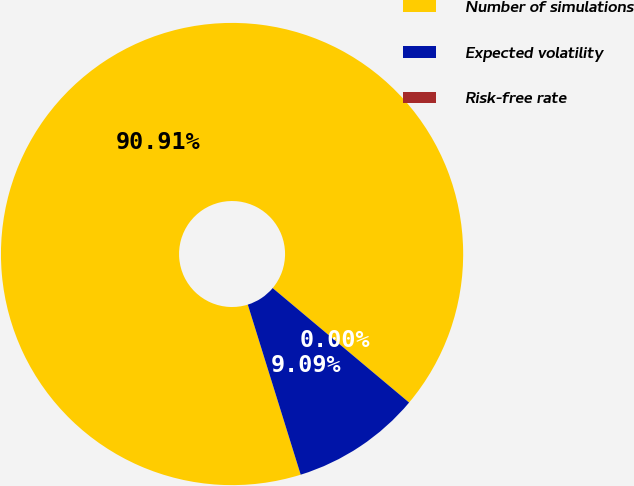Convert chart. <chart><loc_0><loc_0><loc_500><loc_500><pie_chart><fcel>Number of simulations<fcel>Expected volatility<fcel>Risk-free rate<nl><fcel>90.9%<fcel>9.09%<fcel>0.0%<nl></chart> 